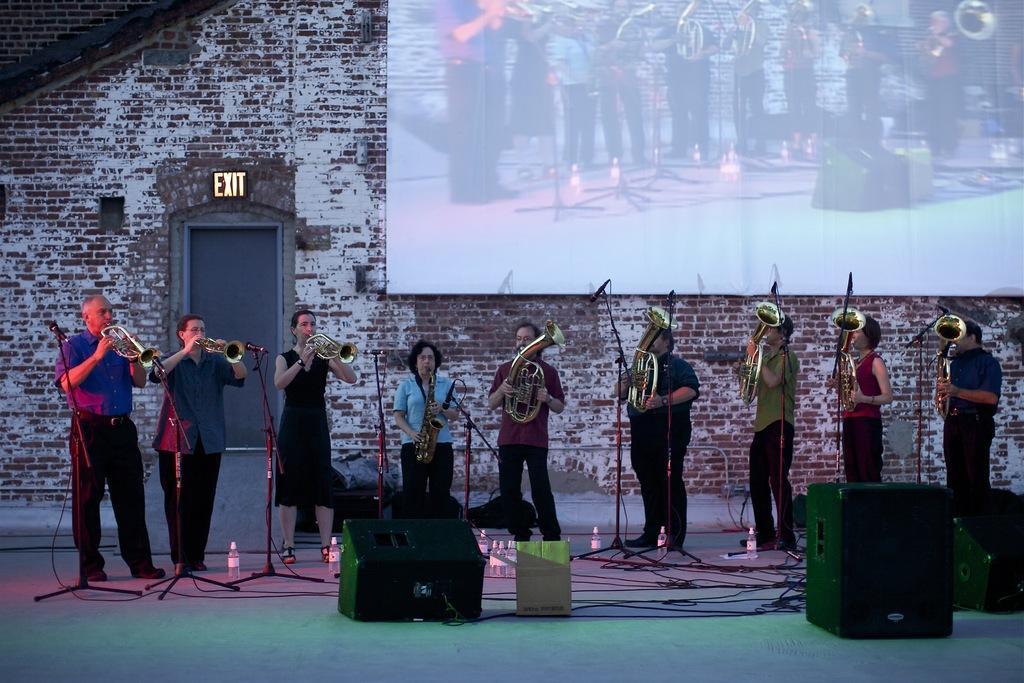How would you summarize this image in a sentence or two? In this image, we can see people holding musical instruments and there are mice along with stands and there are boxes, bottles and wires. In the background, there is a screen and a board on the wall. At the bottom, there is a floor. 